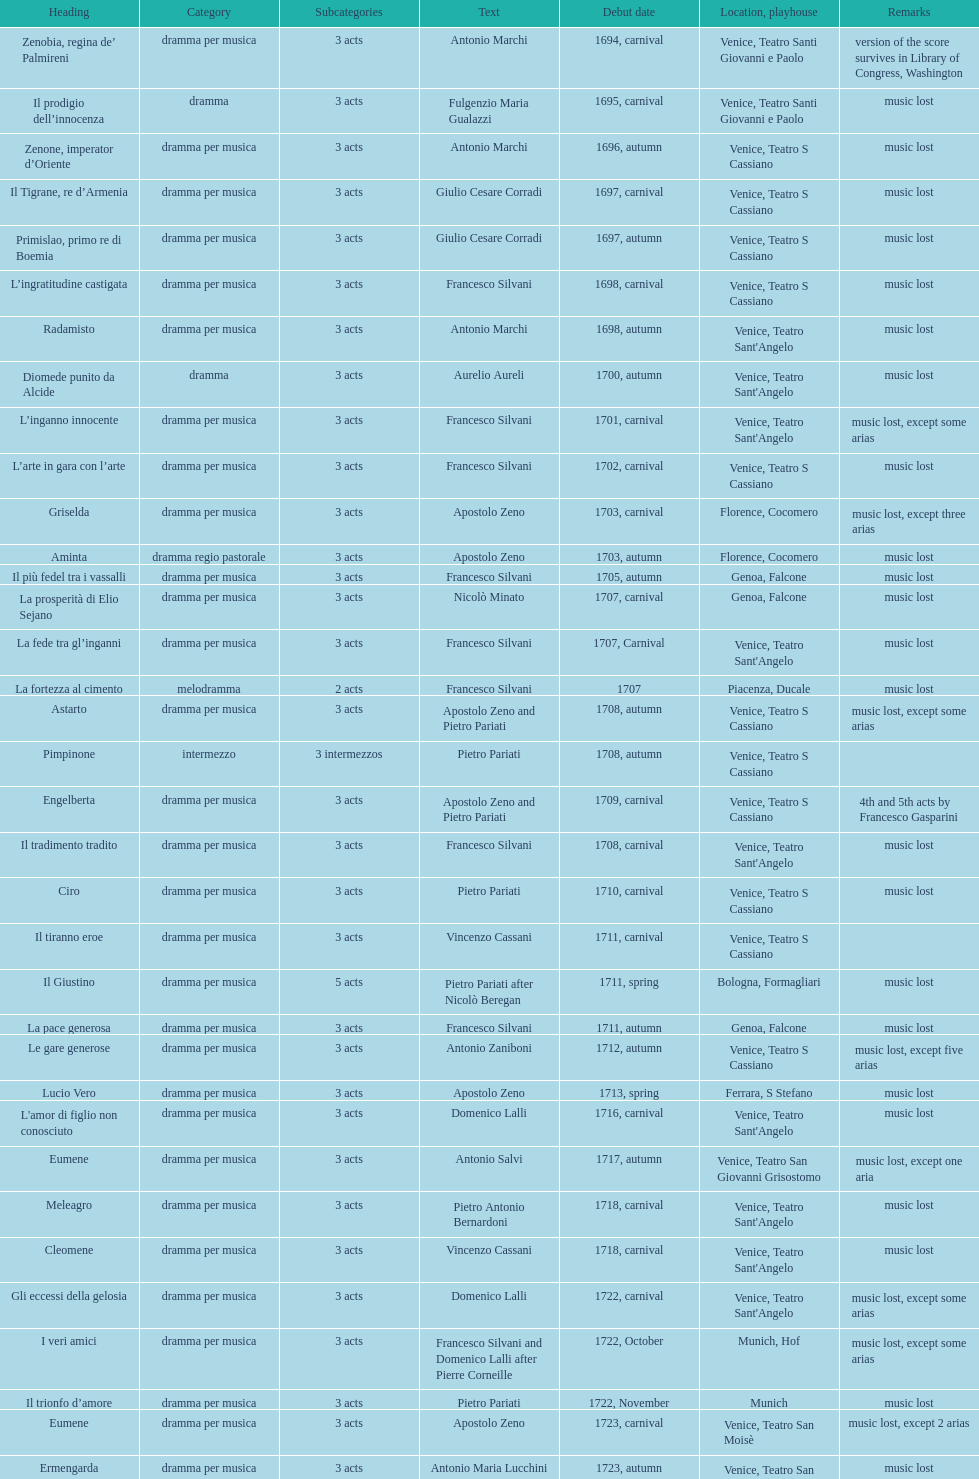What is next after ardelinda? Candalide. 